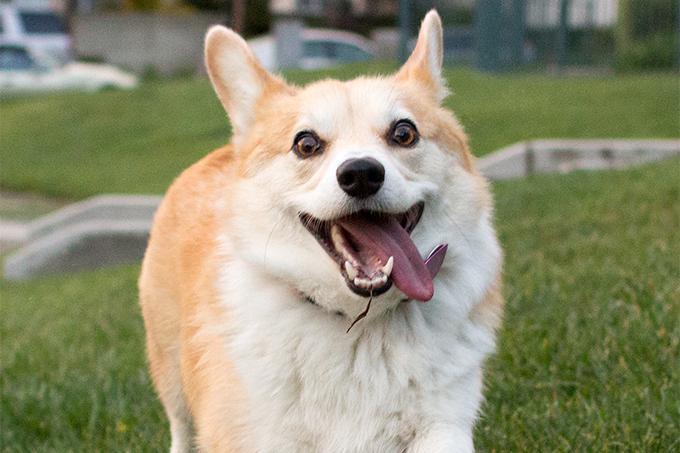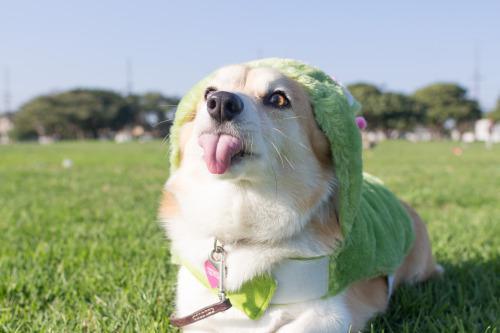The first image is the image on the left, the second image is the image on the right. Given the left and right images, does the statement "At least one dog is sticking the tongue out." hold true? Answer yes or no. Yes. The first image is the image on the left, the second image is the image on the right. Evaluate the accuracy of this statement regarding the images: "All dogs shown are on the grass, and at least two dogs in total have their mouths open and tongues showing.". Is it true? Answer yes or no. Yes. 